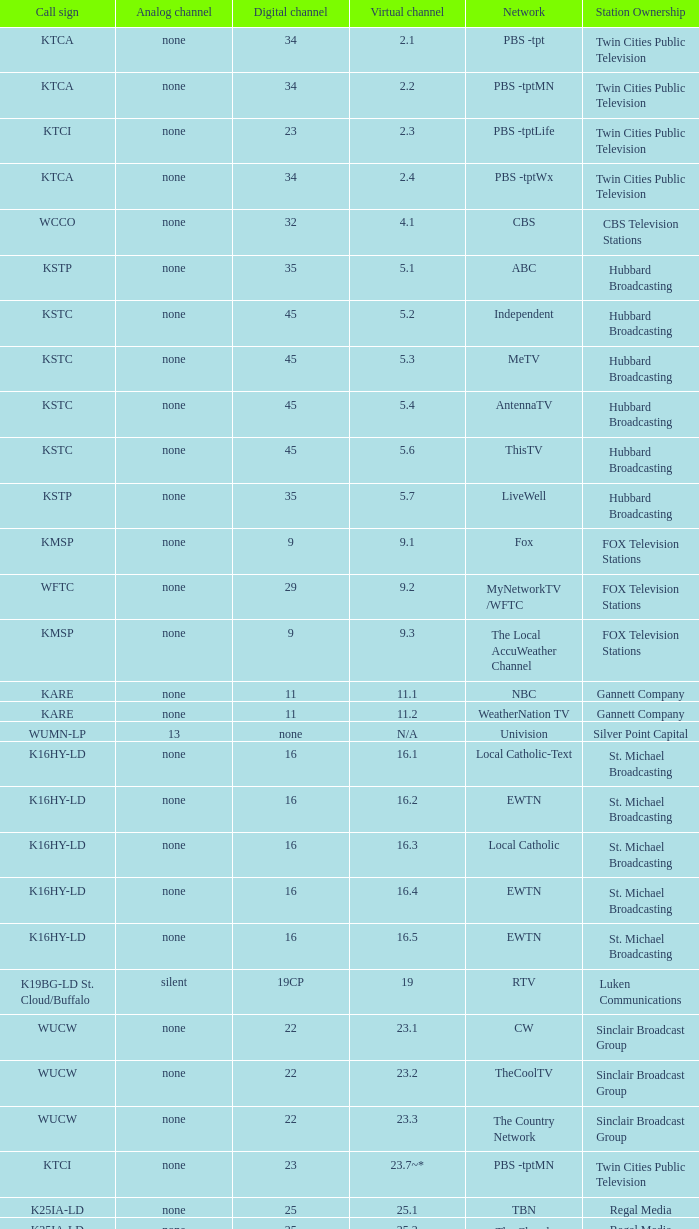Call sign of k33ln-ld, and a Virtual channel of 33.5 is what network? 3ABN Radio-Audio. 